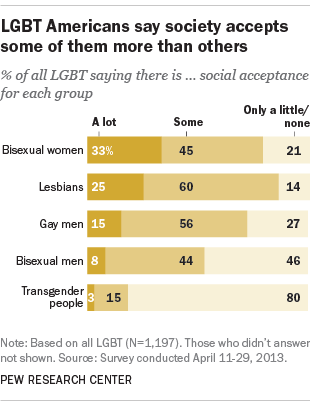Indicate a few pertinent items in this graphic. The darkest part of each bar is located in the leftmost position. According to a study, 71% of gay men reported feeling either "A lot" or "Somewhat" socially accepted. 